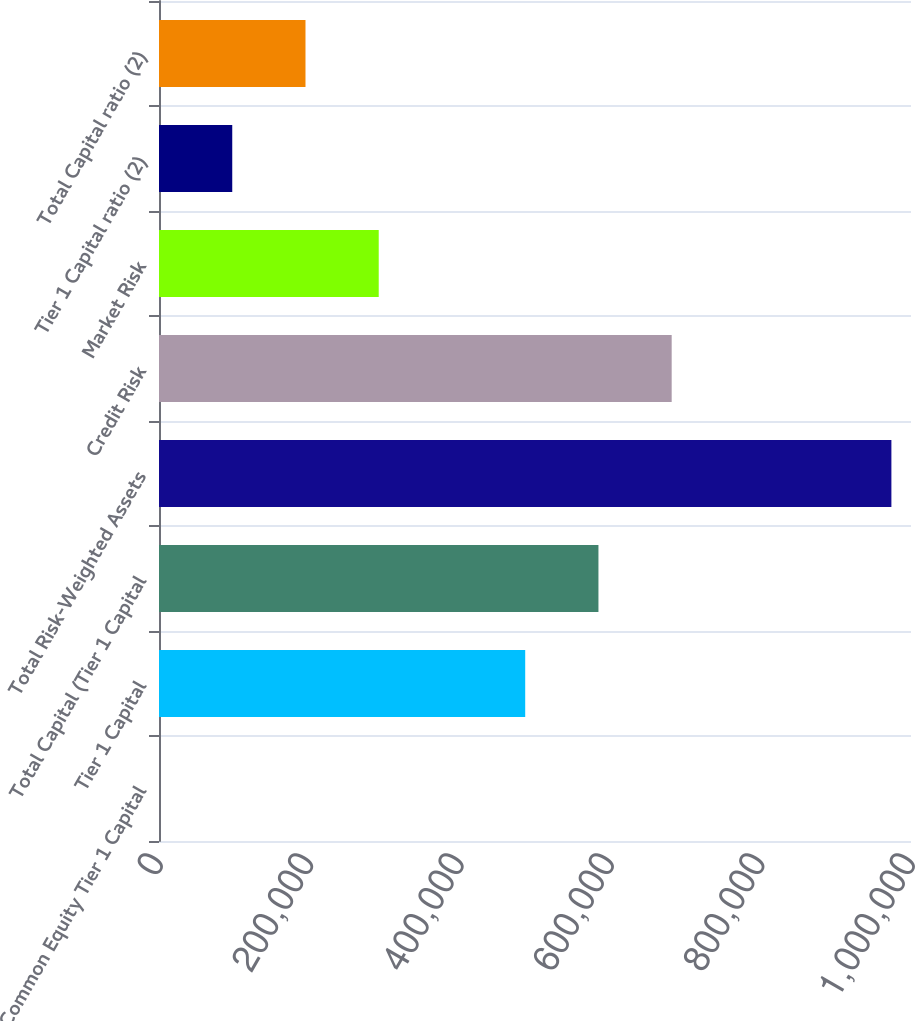<chart> <loc_0><loc_0><loc_500><loc_500><bar_chart><fcel>Common Equity Tier 1 Capital<fcel>Tier 1 Capital<fcel>Total Capital (Tier 1 Capital<fcel>Total Risk-Weighted Assets<fcel>Credit Risk<fcel>Market Risk<fcel>Tier 1 Capital ratio (2)<fcel>Total Capital ratio (2)<nl><fcel>12.96<fcel>486973<fcel>584365<fcel>973933<fcel>681757<fcel>292189<fcel>97405<fcel>194797<nl></chart> 